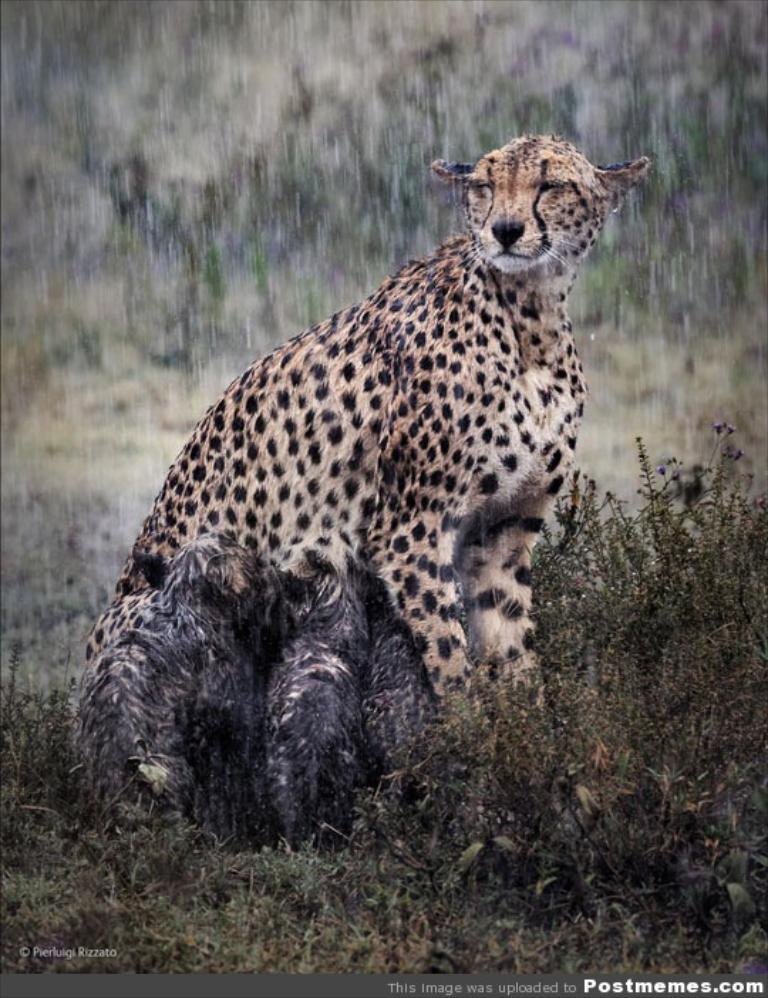What is the weather condition in the image? The image is taken during the rain. What animal is the main subject of the image? There is a cheetah in the center of the image. What type of terrain is the cheetah standing on? The cheetah is on the grass. Is there any text present in the image? Yes, there is text at the bottom of the image. What type of boat can be seen in the image? There is no boat present in the image; it features a cheetah on the grass during the rain. What is the purpose of the cheetah in the image? The image does not indicate a specific purpose for the cheetah; it is simply a photograph of a cheetah in its natural environment. 